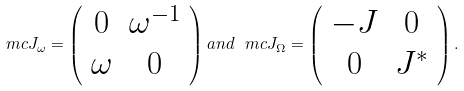<formula> <loc_0><loc_0><loc_500><loc_500>\ m c { J } _ { \omega } = \left ( \begin{array} { c c } 0 & \omega ^ { - 1 } \\ \omega & 0 \end{array} \right ) a n d \, \ m c { J } _ { \Omega } = \left ( \begin{array} { c c } - J & 0 \\ 0 & J ^ { * } \end{array} \right ) .</formula> 